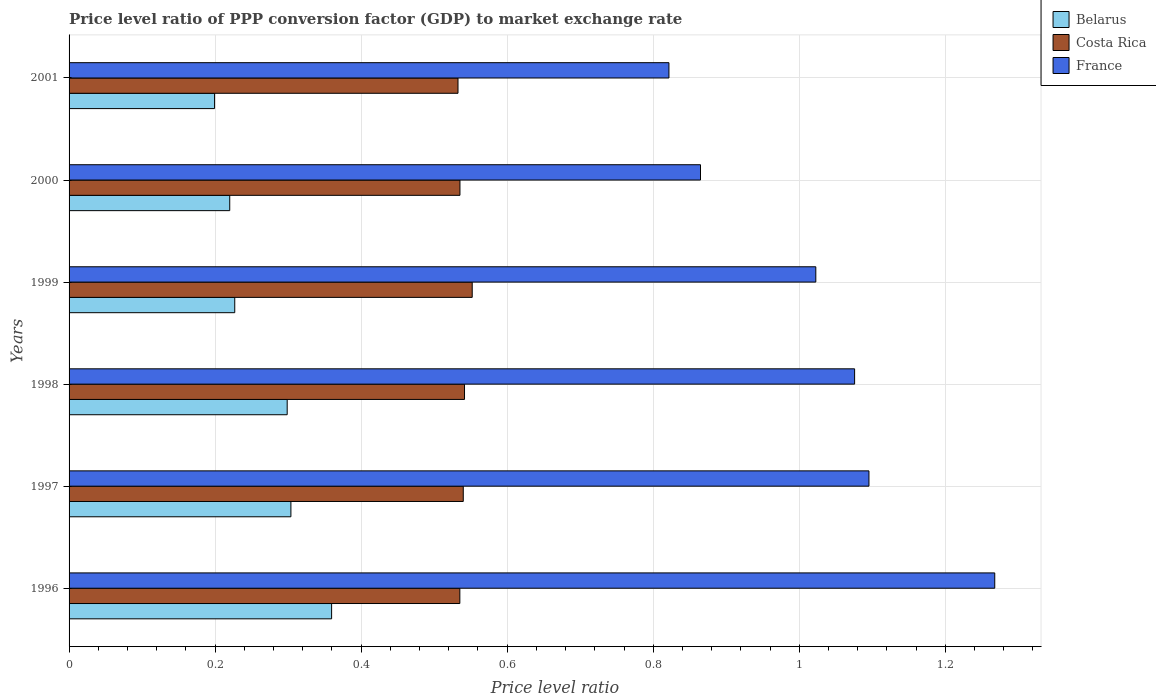Are the number of bars on each tick of the Y-axis equal?
Your answer should be very brief. Yes. In how many cases, is the number of bars for a given year not equal to the number of legend labels?
Your answer should be compact. 0. What is the price level ratio in France in 1997?
Provide a short and direct response. 1.1. Across all years, what is the maximum price level ratio in France?
Ensure brevity in your answer.  1.27. Across all years, what is the minimum price level ratio in Belarus?
Your answer should be very brief. 0.2. In which year was the price level ratio in France minimum?
Provide a succinct answer. 2001. What is the total price level ratio in Costa Rica in the graph?
Give a very brief answer. 3.24. What is the difference between the price level ratio in Costa Rica in 1998 and that in 2000?
Offer a terse response. 0.01. What is the difference between the price level ratio in Costa Rica in 1996 and the price level ratio in France in 2000?
Provide a succinct answer. -0.33. What is the average price level ratio in Costa Rica per year?
Provide a succinct answer. 0.54. In the year 2000, what is the difference between the price level ratio in Belarus and price level ratio in France?
Keep it short and to the point. -0.64. In how many years, is the price level ratio in Belarus greater than 0.36 ?
Make the answer very short. 0. What is the ratio of the price level ratio in Belarus in 1996 to that in 2000?
Your answer should be compact. 1.63. Is the price level ratio in France in 1997 less than that in 2000?
Offer a very short reply. No. What is the difference between the highest and the second highest price level ratio in Costa Rica?
Give a very brief answer. 0.01. What is the difference between the highest and the lowest price level ratio in Belarus?
Provide a short and direct response. 0.16. What does the 1st bar from the top in 1997 represents?
Make the answer very short. France. What does the 2nd bar from the bottom in 2001 represents?
Provide a short and direct response. Costa Rica. How many bars are there?
Give a very brief answer. 18. How many years are there in the graph?
Provide a succinct answer. 6. What is the difference between two consecutive major ticks on the X-axis?
Provide a short and direct response. 0.2. Are the values on the major ticks of X-axis written in scientific E-notation?
Make the answer very short. No. Does the graph contain any zero values?
Make the answer very short. No. How many legend labels are there?
Ensure brevity in your answer.  3. What is the title of the graph?
Your response must be concise. Price level ratio of PPP conversion factor (GDP) to market exchange rate. What is the label or title of the X-axis?
Provide a succinct answer. Price level ratio. What is the Price level ratio in Belarus in 1996?
Keep it short and to the point. 0.36. What is the Price level ratio of Costa Rica in 1996?
Ensure brevity in your answer.  0.54. What is the Price level ratio of France in 1996?
Keep it short and to the point. 1.27. What is the Price level ratio of Belarus in 1997?
Ensure brevity in your answer.  0.3. What is the Price level ratio in Costa Rica in 1997?
Provide a short and direct response. 0.54. What is the Price level ratio in France in 1997?
Your response must be concise. 1.1. What is the Price level ratio in Belarus in 1998?
Give a very brief answer. 0.3. What is the Price level ratio in Costa Rica in 1998?
Provide a short and direct response. 0.54. What is the Price level ratio of France in 1998?
Make the answer very short. 1.08. What is the Price level ratio of Belarus in 1999?
Ensure brevity in your answer.  0.23. What is the Price level ratio in Costa Rica in 1999?
Give a very brief answer. 0.55. What is the Price level ratio of France in 1999?
Offer a terse response. 1.02. What is the Price level ratio of Belarus in 2000?
Provide a succinct answer. 0.22. What is the Price level ratio in Costa Rica in 2000?
Keep it short and to the point. 0.54. What is the Price level ratio in France in 2000?
Make the answer very short. 0.86. What is the Price level ratio of Belarus in 2001?
Offer a very short reply. 0.2. What is the Price level ratio in Costa Rica in 2001?
Give a very brief answer. 0.53. What is the Price level ratio in France in 2001?
Provide a short and direct response. 0.82. Across all years, what is the maximum Price level ratio in Belarus?
Provide a short and direct response. 0.36. Across all years, what is the maximum Price level ratio of Costa Rica?
Give a very brief answer. 0.55. Across all years, what is the maximum Price level ratio of France?
Provide a succinct answer. 1.27. Across all years, what is the minimum Price level ratio in Belarus?
Provide a succinct answer. 0.2. Across all years, what is the minimum Price level ratio of Costa Rica?
Give a very brief answer. 0.53. Across all years, what is the minimum Price level ratio of France?
Make the answer very short. 0.82. What is the total Price level ratio in Belarus in the graph?
Make the answer very short. 1.61. What is the total Price level ratio in Costa Rica in the graph?
Offer a terse response. 3.24. What is the total Price level ratio of France in the graph?
Make the answer very short. 6.15. What is the difference between the Price level ratio in Belarus in 1996 and that in 1997?
Make the answer very short. 0.06. What is the difference between the Price level ratio in Costa Rica in 1996 and that in 1997?
Provide a succinct answer. -0. What is the difference between the Price level ratio in France in 1996 and that in 1997?
Offer a very short reply. 0.17. What is the difference between the Price level ratio of Belarus in 1996 and that in 1998?
Offer a very short reply. 0.06. What is the difference between the Price level ratio of Costa Rica in 1996 and that in 1998?
Your response must be concise. -0.01. What is the difference between the Price level ratio in France in 1996 and that in 1998?
Offer a terse response. 0.19. What is the difference between the Price level ratio in Belarus in 1996 and that in 1999?
Your answer should be very brief. 0.13. What is the difference between the Price level ratio of Costa Rica in 1996 and that in 1999?
Offer a very short reply. -0.02. What is the difference between the Price level ratio of France in 1996 and that in 1999?
Offer a terse response. 0.25. What is the difference between the Price level ratio in Belarus in 1996 and that in 2000?
Give a very brief answer. 0.14. What is the difference between the Price level ratio of Costa Rica in 1996 and that in 2000?
Provide a short and direct response. -0. What is the difference between the Price level ratio in France in 1996 and that in 2000?
Your answer should be very brief. 0.4. What is the difference between the Price level ratio in Belarus in 1996 and that in 2001?
Provide a succinct answer. 0.16. What is the difference between the Price level ratio in Costa Rica in 1996 and that in 2001?
Your answer should be very brief. 0. What is the difference between the Price level ratio in France in 1996 and that in 2001?
Your response must be concise. 0.45. What is the difference between the Price level ratio of Belarus in 1997 and that in 1998?
Give a very brief answer. 0.01. What is the difference between the Price level ratio of Costa Rica in 1997 and that in 1998?
Make the answer very short. -0. What is the difference between the Price level ratio in France in 1997 and that in 1998?
Your answer should be compact. 0.02. What is the difference between the Price level ratio of Belarus in 1997 and that in 1999?
Your response must be concise. 0.08. What is the difference between the Price level ratio in Costa Rica in 1997 and that in 1999?
Provide a succinct answer. -0.01. What is the difference between the Price level ratio in France in 1997 and that in 1999?
Offer a terse response. 0.07. What is the difference between the Price level ratio of Belarus in 1997 and that in 2000?
Your response must be concise. 0.08. What is the difference between the Price level ratio of Costa Rica in 1997 and that in 2000?
Your answer should be compact. 0. What is the difference between the Price level ratio in France in 1997 and that in 2000?
Ensure brevity in your answer.  0.23. What is the difference between the Price level ratio in Belarus in 1997 and that in 2001?
Your answer should be compact. 0.1. What is the difference between the Price level ratio of Costa Rica in 1997 and that in 2001?
Give a very brief answer. 0.01. What is the difference between the Price level ratio in France in 1997 and that in 2001?
Keep it short and to the point. 0.27. What is the difference between the Price level ratio in Belarus in 1998 and that in 1999?
Your answer should be very brief. 0.07. What is the difference between the Price level ratio in Costa Rica in 1998 and that in 1999?
Ensure brevity in your answer.  -0.01. What is the difference between the Price level ratio of France in 1998 and that in 1999?
Your response must be concise. 0.05. What is the difference between the Price level ratio in Belarus in 1998 and that in 2000?
Your answer should be compact. 0.08. What is the difference between the Price level ratio of Costa Rica in 1998 and that in 2000?
Offer a very short reply. 0.01. What is the difference between the Price level ratio of France in 1998 and that in 2000?
Your answer should be compact. 0.21. What is the difference between the Price level ratio in Belarus in 1998 and that in 2001?
Your response must be concise. 0.1. What is the difference between the Price level ratio in Costa Rica in 1998 and that in 2001?
Your response must be concise. 0.01. What is the difference between the Price level ratio in France in 1998 and that in 2001?
Your answer should be compact. 0.25. What is the difference between the Price level ratio of Belarus in 1999 and that in 2000?
Keep it short and to the point. 0.01. What is the difference between the Price level ratio of Costa Rica in 1999 and that in 2000?
Offer a terse response. 0.02. What is the difference between the Price level ratio of France in 1999 and that in 2000?
Ensure brevity in your answer.  0.16. What is the difference between the Price level ratio of Belarus in 1999 and that in 2001?
Provide a short and direct response. 0.03. What is the difference between the Price level ratio in Costa Rica in 1999 and that in 2001?
Ensure brevity in your answer.  0.02. What is the difference between the Price level ratio of France in 1999 and that in 2001?
Provide a succinct answer. 0.2. What is the difference between the Price level ratio in Belarus in 2000 and that in 2001?
Keep it short and to the point. 0.02. What is the difference between the Price level ratio of Costa Rica in 2000 and that in 2001?
Provide a short and direct response. 0. What is the difference between the Price level ratio of France in 2000 and that in 2001?
Give a very brief answer. 0.04. What is the difference between the Price level ratio in Belarus in 1996 and the Price level ratio in Costa Rica in 1997?
Make the answer very short. -0.18. What is the difference between the Price level ratio in Belarus in 1996 and the Price level ratio in France in 1997?
Provide a short and direct response. -0.74. What is the difference between the Price level ratio of Costa Rica in 1996 and the Price level ratio of France in 1997?
Offer a terse response. -0.56. What is the difference between the Price level ratio in Belarus in 1996 and the Price level ratio in Costa Rica in 1998?
Ensure brevity in your answer.  -0.18. What is the difference between the Price level ratio of Belarus in 1996 and the Price level ratio of France in 1998?
Keep it short and to the point. -0.72. What is the difference between the Price level ratio of Costa Rica in 1996 and the Price level ratio of France in 1998?
Make the answer very short. -0.54. What is the difference between the Price level ratio in Belarus in 1996 and the Price level ratio in Costa Rica in 1999?
Your answer should be compact. -0.19. What is the difference between the Price level ratio of Belarus in 1996 and the Price level ratio of France in 1999?
Provide a succinct answer. -0.66. What is the difference between the Price level ratio of Costa Rica in 1996 and the Price level ratio of France in 1999?
Keep it short and to the point. -0.49. What is the difference between the Price level ratio of Belarus in 1996 and the Price level ratio of Costa Rica in 2000?
Give a very brief answer. -0.18. What is the difference between the Price level ratio in Belarus in 1996 and the Price level ratio in France in 2000?
Provide a short and direct response. -0.51. What is the difference between the Price level ratio in Costa Rica in 1996 and the Price level ratio in France in 2000?
Your answer should be very brief. -0.33. What is the difference between the Price level ratio in Belarus in 1996 and the Price level ratio in Costa Rica in 2001?
Offer a very short reply. -0.17. What is the difference between the Price level ratio of Belarus in 1996 and the Price level ratio of France in 2001?
Your answer should be compact. -0.46. What is the difference between the Price level ratio of Costa Rica in 1996 and the Price level ratio of France in 2001?
Keep it short and to the point. -0.29. What is the difference between the Price level ratio in Belarus in 1997 and the Price level ratio in Costa Rica in 1998?
Your response must be concise. -0.24. What is the difference between the Price level ratio of Belarus in 1997 and the Price level ratio of France in 1998?
Keep it short and to the point. -0.77. What is the difference between the Price level ratio in Costa Rica in 1997 and the Price level ratio in France in 1998?
Keep it short and to the point. -0.54. What is the difference between the Price level ratio in Belarus in 1997 and the Price level ratio in Costa Rica in 1999?
Your answer should be compact. -0.25. What is the difference between the Price level ratio in Belarus in 1997 and the Price level ratio in France in 1999?
Ensure brevity in your answer.  -0.72. What is the difference between the Price level ratio in Costa Rica in 1997 and the Price level ratio in France in 1999?
Provide a succinct answer. -0.48. What is the difference between the Price level ratio in Belarus in 1997 and the Price level ratio in Costa Rica in 2000?
Your response must be concise. -0.23. What is the difference between the Price level ratio of Belarus in 1997 and the Price level ratio of France in 2000?
Keep it short and to the point. -0.56. What is the difference between the Price level ratio of Costa Rica in 1997 and the Price level ratio of France in 2000?
Keep it short and to the point. -0.32. What is the difference between the Price level ratio in Belarus in 1997 and the Price level ratio in Costa Rica in 2001?
Ensure brevity in your answer.  -0.23. What is the difference between the Price level ratio of Belarus in 1997 and the Price level ratio of France in 2001?
Your answer should be very brief. -0.52. What is the difference between the Price level ratio in Costa Rica in 1997 and the Price level ratio in France in 2001?
Give a very brief answer. -0.28. What is the difference between the Price level ratio in Belarus in 1998 and the Price level ratio in Costa Rica in 1999?
Your answer should be compact. -0.25. What is the difference between the Price level ratio in Belarus in 1998 and the Price level ratio in France in 1999?
Offer a very short reply. -0.72. What is the difference between the Price level ratio in Costa Rica in 1998 and the Price level ratio in France in 1999?
Provide a short and direct response. -0.48. What is the difference between the Price level ratio of Belarus in 1998 and the Price level ratio of Costa Rica in 2000?
Your response must be concise. -0.24. What is the difference between the Price level ratio in Belarus in 1998 and the Price level ratio in France in 2000?
Your answer should be compact. -0.57. What is the difference between the Price level ratio of Costa Rica in 1998 and the Price level ratio of France in 2000?
Make the answer very short. -0.32. What is the difference between the Price level ratio in Belarus in 1998 and the Price level ratio in Costa Rica in 2001?
Ensure brevity in your answer.  -0.23. What is the difference between the Price level ratio of Belarus in 1998 and the Price level ratio of France in 2001?
Give a very brief answer. -0.52. What is the difference between the Price level ratio of Costa Rica in 1998 and the Price level ratio of France in 2001?
Make the answer very short. -0.28. What is the difference between the Price level ratio of Belarus in 1999 and the Price level ratio of Costa Rica in 2000?
Ensure brevity in your answer.  -0.31. What is the difference between the Price level ratio in Belarus in 1999 and the Price level ratio in France in 2000?
Make the answer very short. -0.64. What is the difference between the Price level ratio of Costa Rica in 1999 and the Price level ratio of France in 2000?
Offer a very short reply. -0.31. What is the difference between the Price level ratio in Belarus in 1999 and the Price level ratio in Costa Rica in 2001?
Provide a short and direct response. -0.31. What is the difference between the Price level ratio in Belarus in 1999 and the Price level ratio in France in 2001?
Ensure brevity in your answer.  -0.59. What is the difference between the Price level ratio in Costa Rica in 1999 and the Price level ratio in France in 2001?
Provide a short and direct response. -0.27. What is the difference between the Price level ratio in Belarus in 2000 and the Price level ratio in Costa Rica in 2001?
Your answer should be very brief. -0.31. What is the difference between the Price level ratio in Belarus in 2000 and the Price level ratio in France in 2001?
Your answer should be very brief. -0.6. What is the difference between the Price level ratio in Costa Rica in 2000 and the Price level ratio in France in 2001?
Provide a succinct answer. -0.29. What is the average Price level ratio of Belarus per year?
Your answer should be very brief. 0.27. What is the average Price level ratio of Costa Rica per year?
Keep it short and to the point. 0.54. What is the average Price level ratio in France per year?
Your response must be concise. 1.02. In the year 1996, what is the difference between the Price level ratio of Belarus and Price level ratio of Costa Rica?
Make the answer very short. -0.18. In the year 1996, what is the difference between the Price level ratio in Belarus and Price level ratio in France?
Provide a succinct answer. -0.91. In the year 1996, what is the difference between the Price level ratio in Costa Rica and Price level ratio in France?
Ensure brevity in your answer.  -0.73. In the year 1997, what is the difference between the Price level ratio of Belarus and Price level ratio of Costa Rica?
Offer a very short reply. -0.24. In the year 1997, what is the difference between the Price level ratio in Belarus and Price level ratio in France?
Ensure brevity in your answer.  -0.79. In the year 1997, what is the difference between the Price level ratio of Costa Rica and Price level ratio of France?
Ensure brevity in your answer.  -0.56. In the year 1998, what is the difference between the Price level ratio of Belarus and Price level ratio of Costa Rica?
Ensure brevity in your answer.  -0.24. In the year 1998, what is the difference between the Price level ratio of Belarus and Price level ratio of France?
Provide a short and direct response. -0.78. In the year 1998, what is the difference between the Price level ratio of Costa Rica and Price level ratio of France?
Provide a short and direct response. -0.53. In the year 1999, what is the difference between the Price level ratio in Belarus and Price level ratio in Costa Rica?
Make the answer very short. -0.33. In the year 1999, what is the difference between the Price level ratio in Belarus and Price level ratio in France?
Ensure brevity in your answer.  -0.8. In the year 1999, what is the difference between the Price level ratio of Costa Rica and Price level ratio of France?
Provide a succinct answer. -0.47. In the year 2000, what is the difference between the Price level ratio in Belarus and Price level ratio in Costa Rica?
Your answer should be compact. -0.32. In the year 2000, what is the difference between the Price level ratio in Belarus and Price level ratio in France?
Keep it short and to the point. -0.64. In the year 2000, what is the difference between the Price level ratio in Costa Rica and Price level ratio in France?
Ensure brevity in your answer.  -0.33. In the year 2001, what is the difference between the Price level ratio in Belarus and Price level ratio in Costa Rica?
Your answer should be very brief. -0.33. In the year 2001, what is the difference between the Price level ratio in Belarus and Price level ratio in France?
Your response must be concise. -0.62. In the year 2001, what is the difference between the Price level ratio of Costa Rica and Price level ratio of France?
Ensure brevity in your answer.  -0.29. What is the ratio of the Price level ratio of Belarus in 1996 to that in 1997?
Ensure brevity in your answer.  1.18. What is the ratio of the Price level ratio in Costa Rica in 1996 to that in 1997?
Your response must be concise. 0.99. What is the ratio of the Price level ratio of France in 1996 to that in 1997?
Your answer should be compact. 1.16. What is the ratio of the Price level ratio of Belarus in 1996 to that in 1998?
Keep it short and to the point. 1.2. What is the ratio of the Price level ratio in Costa Rica in 1996 to that in 1998?
Ensure brevity in your answer.  0.99. What is the ratio of the Price level ratio in France in 1996 to that in 1998?
Provide a succinct answer. 1.18. What is the ratio of the Price level ratio in Belarus in 1996 to that in 1999?
Your answer should be very brief. 1.58. What is the ratio of the Price level ratio of Costa Rica in 1996 to that in 1999?
Give a very brief answer. 0.97. What is the ratio of the Price level ratio of France in 1996 to that in 1999?
Keep it short and to the point. 1.24. What is the ratio of the Price level ratio of Belarus in 1996 to that in 2000?
Offer a very short reply. 1.63. What is the ratio of the Price level ratio in France in 1996 to that in 2000?
Make the answer very short. 1.47. What is the ratio of the Price level ratio of Belarus in 1996 to that in 2001?
Offer a terse response. 1.8. What is the ratio of the Price level ratio in Costa Rica in 1996 to that in 2001?
Your response must be concise. 1. What is the ratio of the Price level ratio of France in 1996 to that in 2001?
Give a very brief answer. 1.54. What is the ratio of the Price level ratio of Belarus in 1997 to that in 1998?
Keep it short and to the point. 1.02. What is the ratio of the Price level ratio in Costa Rica in 1997 to that in 1998?
Provide a short and direct response. 1. What is the ratio of the Price level ratio of France in 1997 to that in 1998?
Keep it short and to the point. 1.02. What is the ratio of the Price level ratio in Belarus in 1997 to that in 1999?
Ensure brevity in your answer.  1.34. What is the ratio of the Price level ratio of Costa Rica in 1997 to that in 1999?
Keep it short and to the point. 0.98. What is the ratio of the Price level ratio in France in 1997 to that in 1999?
Offer a very short reply. 1.07. What is the ratio of the Price level ratio of Belarus in 1997 to that in 2000?
Provide a succinct answer. 1.38. What is the ratio of the Price level ratio of Costa Rica in 1997 to that in 2000?
Provide a succinct answer. 1.01. What is the ratio of the Price level ratio of France in 1997 to that in 2000?
Provide a succinct answer. 1.27. What is the ratio of the Price level ratio of Belarus in 1997 to that in 2001?
Ensure brevity in your answer.  1.52. What is the ratio of the Price level ratio in Costa Rica in 1997 to that in 2001?
Offer a very short reply. 1.01. What is the ratio of the Price level ratio in France in 1997 to that in 2001?
Your response must be concise. 1.33. What is the ratio of the Price level ratio of Belarus in 1998 to that in 1999?
Give a very brief answer. 1.32. What is the ratio of the Price level ratio of Costa Rica in 1998 to that in 1999?
Make the answer very short. 0.98. What is the ratio of the Price level ratio in France in 1998 to that in 1999?
Your answer should be very brief. 1.05. What is the ratio of the Price level ratio in Belarus in 1998 to that in 2000?
Your answer should be very brief. 1.36. What is the ratio of the Price level ratio of Costa Rica in 1998 to that in 2000?
Keep it short and to the point. 1.01. What is the ratio of the Price level ratio in France in 1998 to that in 2000?
Your response must be concise. 1.24. What is the ratio of the Price level ratio in Belarus in 1998 to that in 2001?
Your answer should be very brief. 1.5. What is the ratio of the Price level ratio in Costa Rica in 1998 to that in 2001?
Offer a terse response. 1.02. What is the ratio of the Price level ratio of France in 1998 to that in 2001?
Keep it short and to the point. 1.31. What is the ratio of the Price level ratio of Belarus in 1999 to that in 2000?
Ensure brevity in your answer.  1.03. What is the ratio of the Price level ratio of Costa Rica in 1999 to that in 2000?
Offer a very short reply. 1.03. What is the ratio of the Price level ratio of France in 1999 to that in 2000?
Your answer should be compact. 1.18. What is the ratio of the Price level ratio of Belarus in 1999 to that in 2001?
Give a very brief answer. 1.14. What is the ratio of the Price level ratio in Costa Rica in 1999 to that in 2001?
Your answer should be very brief. 1.04. What is the ratio of the Price level ratio in France in 1999 to that in 2001?
Make the answer very short. 1.24. What is the ratio of the Price level ratio of Belarus in 2000 to that in 2001?
Offer a very short reply. 1.1. What is the ratio of the Price level ratio in Costa Rica in 2000 to that in 2001?
Give a very brief answer. 1. What is the ratio of the Price level ratio in France in 2000 to that in 2001?
Provide a succinct answer. 1.05. What is the difference between the highest and the second highest Price level ratio of Belarus?
Ensure brevity in your answer.  0.06. What is the difference between the highest and the second highest Price level ratio of Costa Rica?
Your answer should be very brief. 0.01. What is the difference between the highest and the second highest Price level ratio in France?
Your answer should be compact. 0.17. What is the difference between the highest and the lowest Price level ratio in Belarus?
Ensure brevity in your answer.  0.16. What is the difference between the highest and the lowest Price level ratio of Costa Rica?
Provide a succinct answer. 0.02. What is the difference between the highest and the lowest Price level ratio of France?
Offer a very short reply. 0.45. 